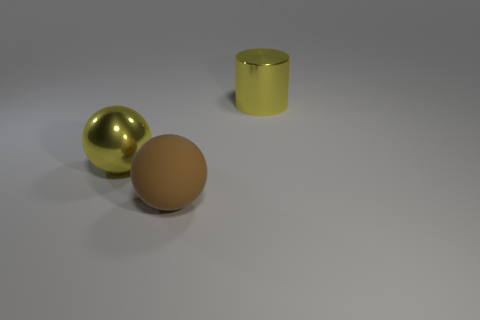Add 3 large objects. How many objects exist? 6 Subtract all balls. How many objects are left? 1 Subtract 0 cyan balls. How many objects are left? 3 Subtract all small green metal cylinders. Subtract all metal balls. How many objects are left? 2 Add 1 cylinders. How many cylinders are left? 2 Add 2 large purple objects. How many large purple objects exist? 2 